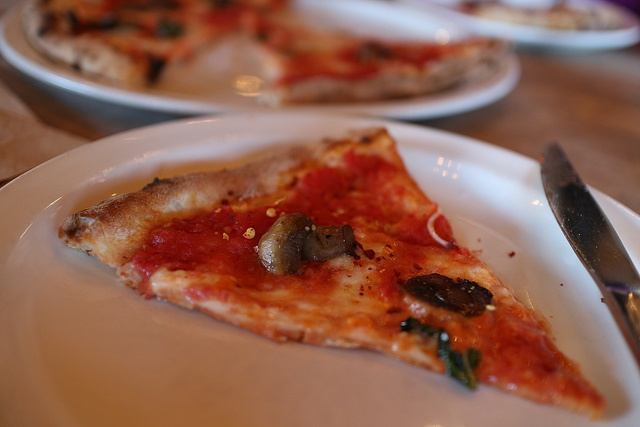Describe the objects in this image and their specific colors. I can see dining table in gray, brown, maroon, and darkgray tones, pizza in gray, maroon, and brown tones, pizza in gray, maroon, and brown tones, knife in gray, black, and maroon tones, and pizza in gray and darkgray tones in this image. 